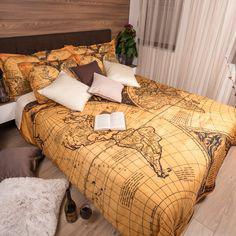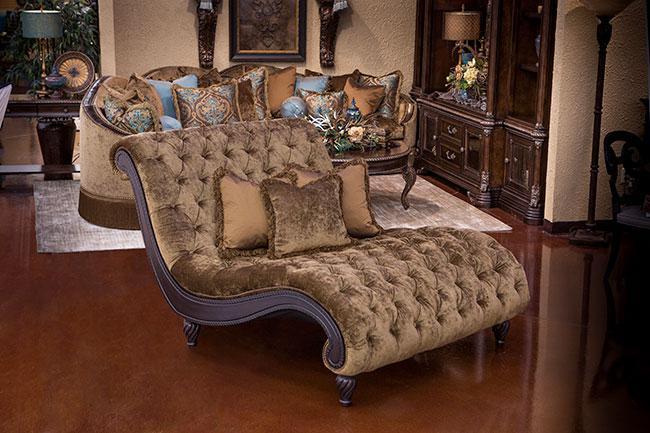The first image is the image on the left, the second image is the image on the right. Evaluate the accuracy of this statement regarding the images: "In at least one image, no framed wall art is displayed in the bedroom.". Is it true? Answer yes or no. Yes. 